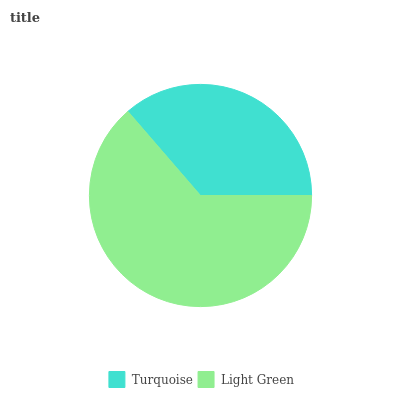Is Turquoise the minimum?
Answer yes or no. Yes. Is Light Green the maximum?
Answer yes or no. Yes. Is Light Green the minimum?
Answer yes or no. No. Is Light Green greater than Turquoise?
Answer yes or no. Yes. Is Turquoise less than Light Green?
Answer yes or no. Yes. Is Turquoise greater than Light Green?
Answer yes or no. No. Is Light Green less than Turquoise?
Answer yes or no. No. Is Light Green the high median?
Answer yes or no. Yes. Is Turquoise the low median?
Answer yes or no. Yes. Is Turquoise the high median?
Answer yes or no. No. Is Light Green the low median?
Answer yes or no. No. 